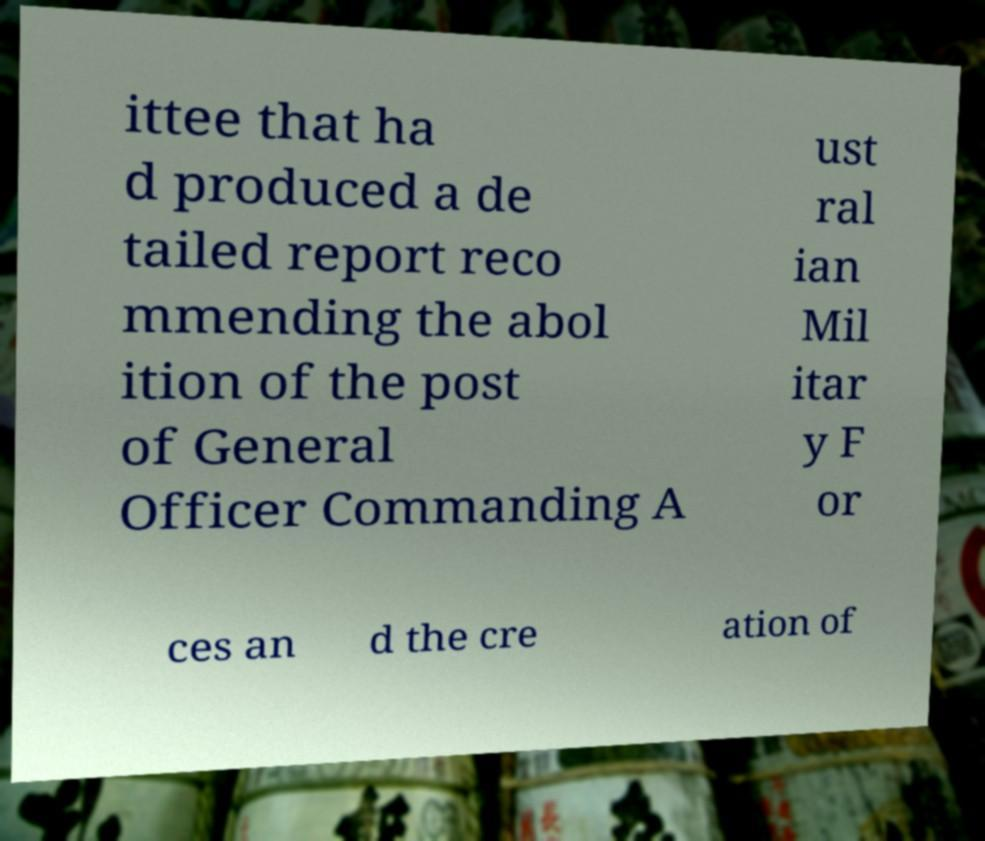Please read and relay the text visible in this image. What does it say? ittee that ha d produced a de tailed report reco mmending the abol ition of the post of General Officer Commanding A ust ral ian Mil itar y F or ces an d the cre ation of 